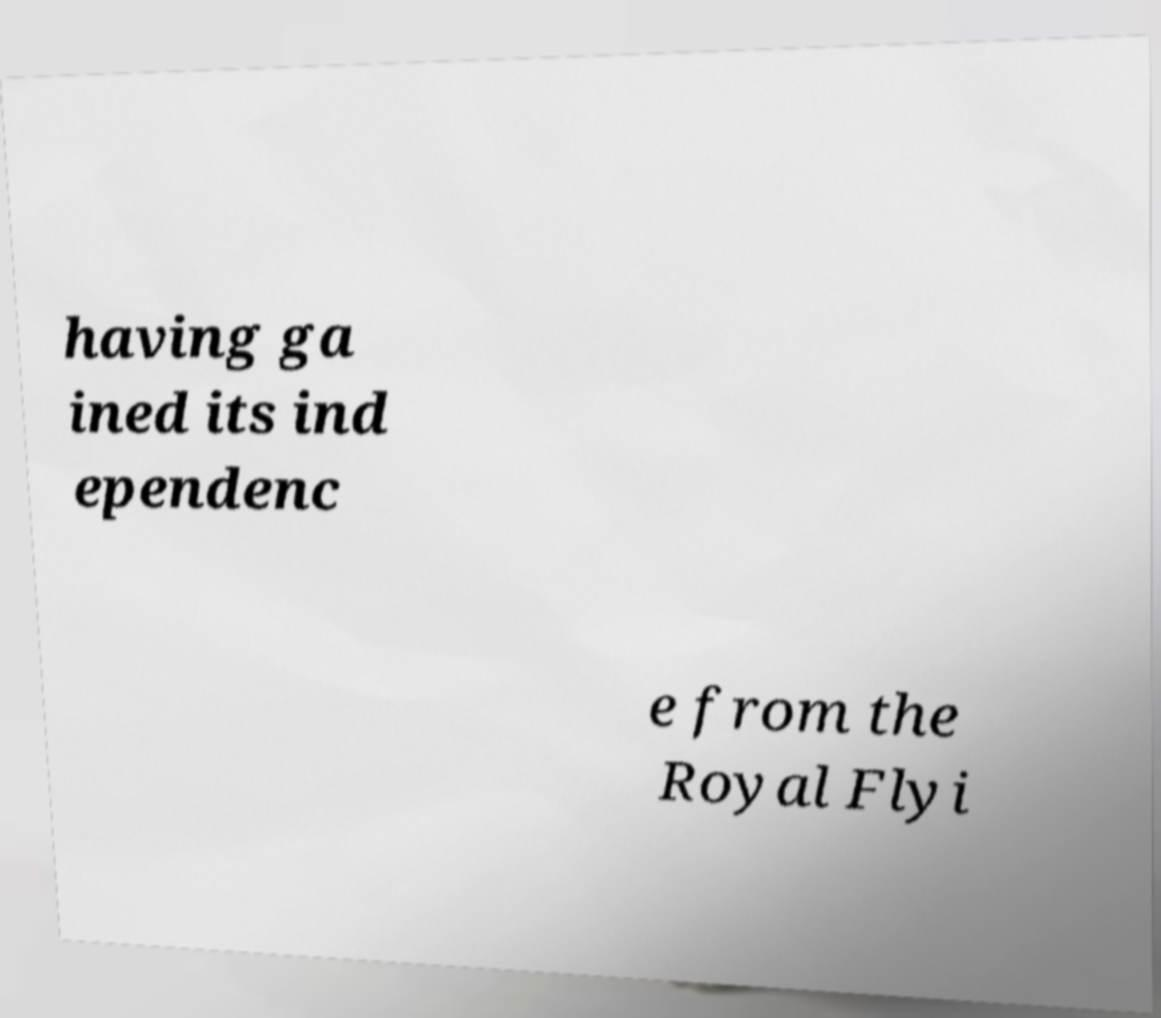Please read and relay the text visible in this image. What does it say? having ga ined its ind ependenc e from the Royal Flyi 